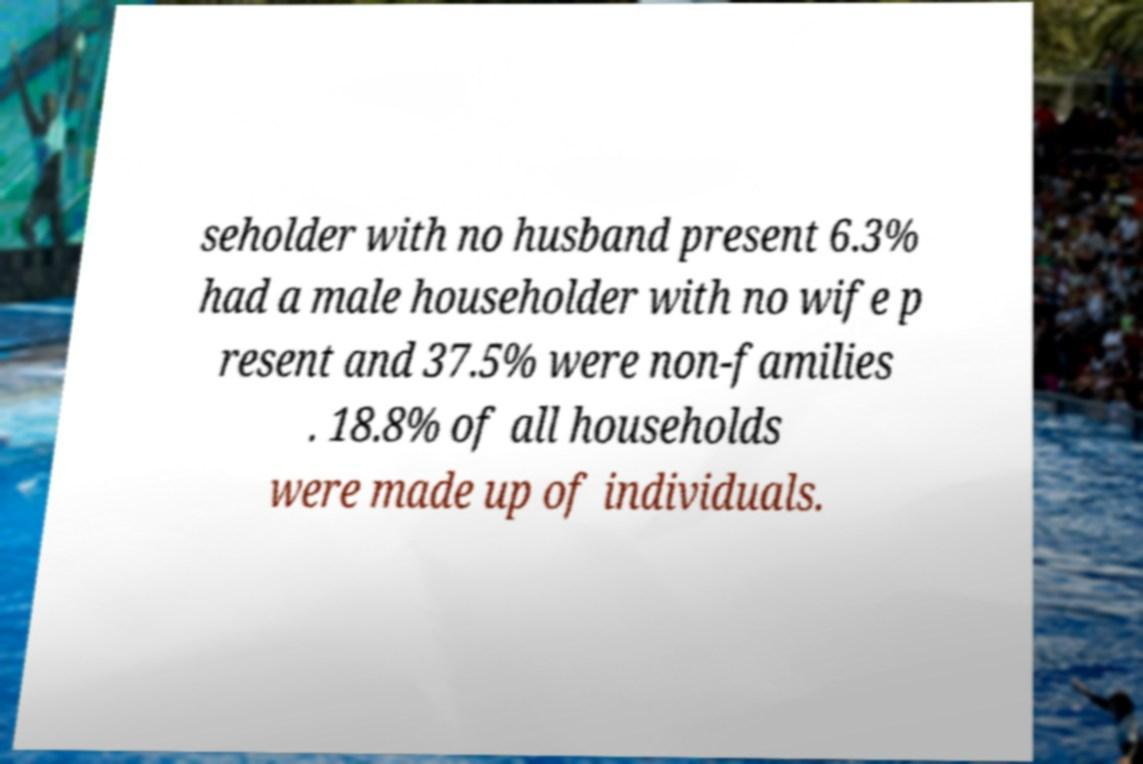Could you extract and type out the text from this image? seholder with no husband present 6.3% had a male householder with no wife p resent and 37.5% were non-families . 18.8% of all households were made up of individuals. 